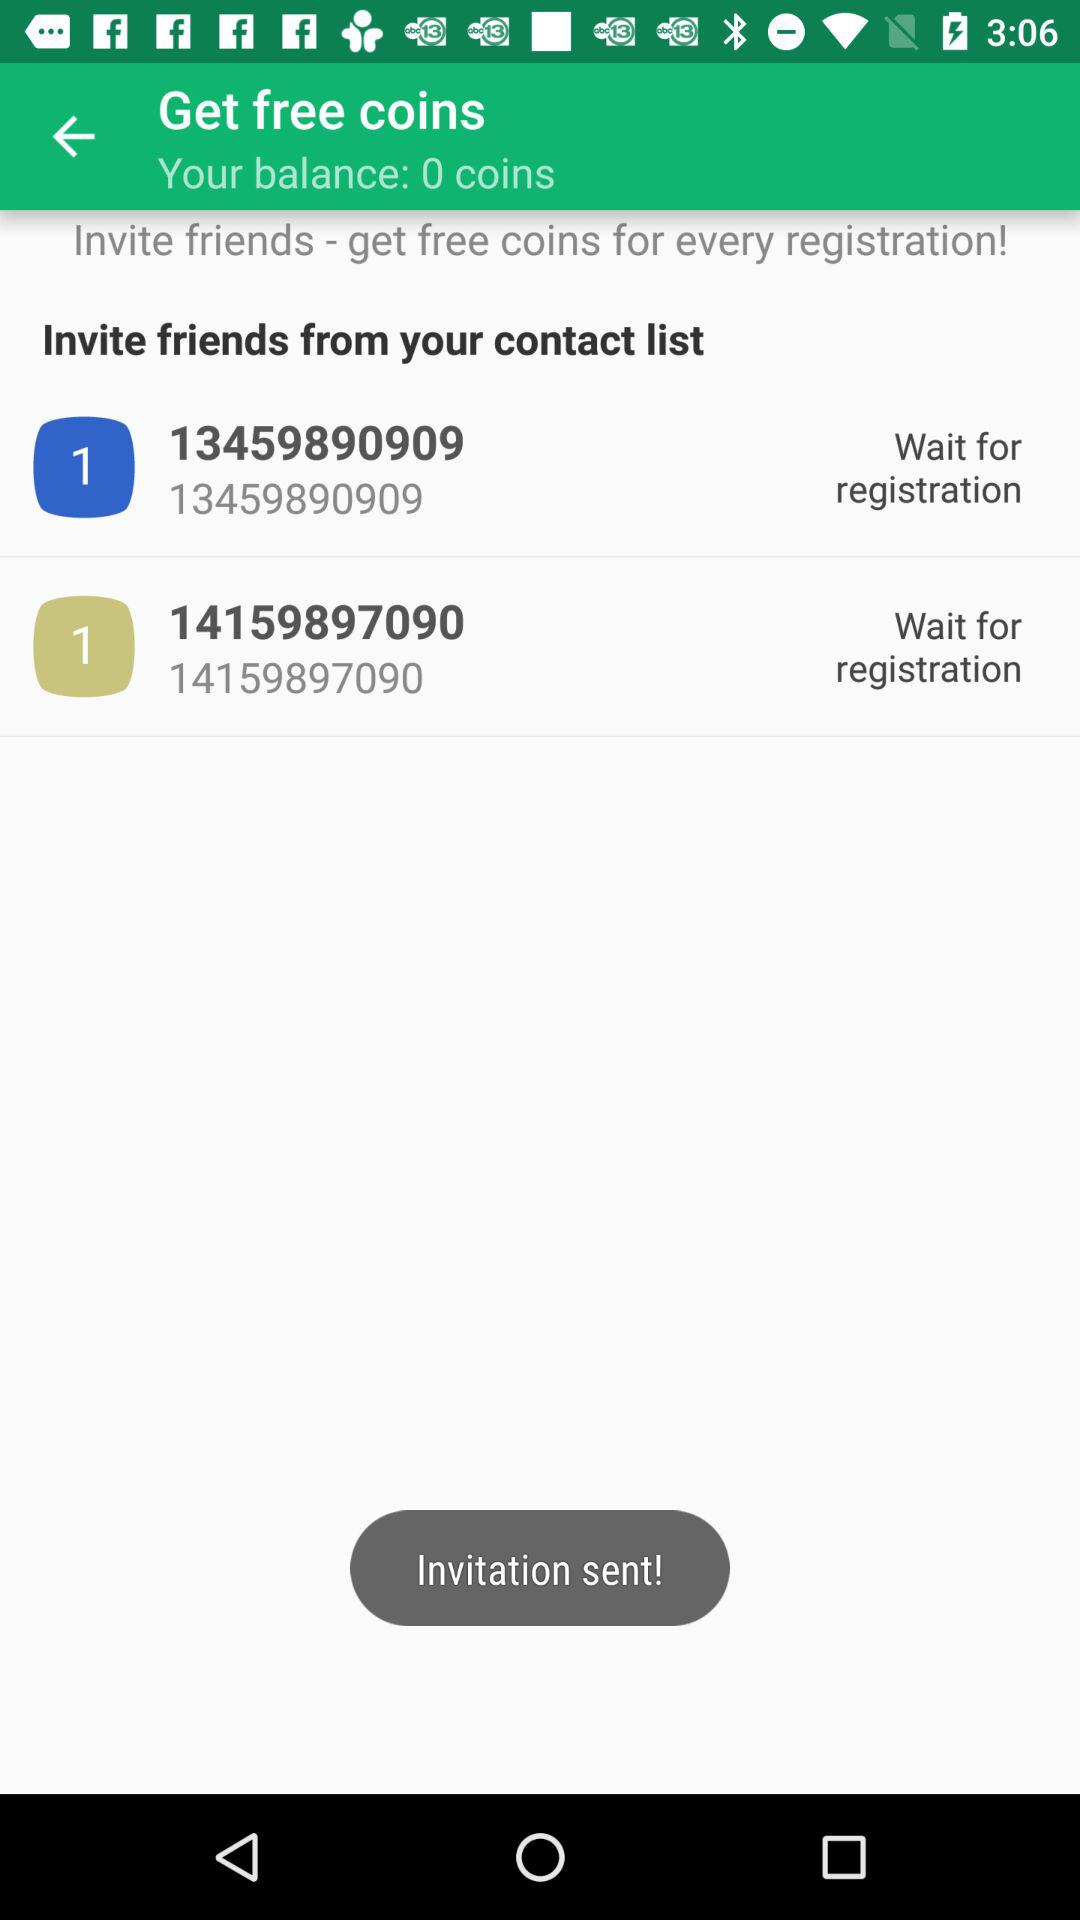How many friends have I invited?
Answer the question using a single word or phrase. 2 